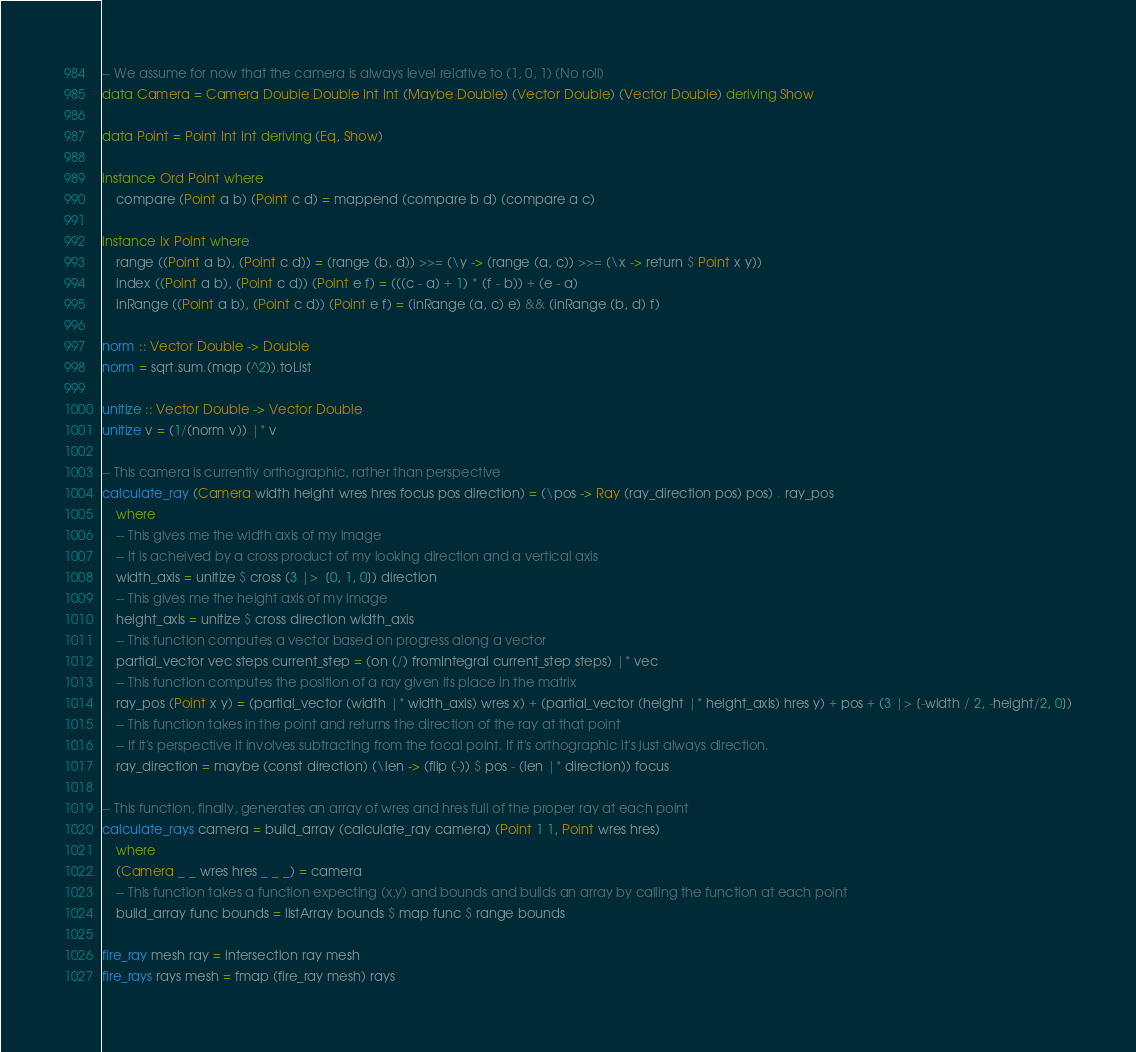<code> <loc_0><loc_0><loc_500><loc_500><_Haskell_>-- We assume for now that the camera is always level relative to (1, 0, 1) (No roll)
data Camera = Camera Double Double Int Int (Maybe Double) (Vector Double) (Vector Double) deriving Show

data Point = Point Int Int deriving (Eq, Show)

instance Ord Point where
	compare (Point a b) (Point c d) = mappend (compare b d) (compare a c)

instance Ix Point where
	range ((Point a b), (Point c d)) = (range (b, d)) >>= (\y -> (range (a, c)) >>= (\x -> return $ Point x y))
	index ((Point a b), (Point c d)) (Point e f) = (((c - a) + 1) * (f - b)) + (e - a)
	inRange ((Point a b), (Point c d)) (Point e f) = (inRange (a, c) e) && (inRange (b, d) f)

norm :: Vector Double -> Double
norm = sqrt.sum.(map (^2)).toList

unitize :: Vector Double -> Vector Double
unitize v = (1/(norm v)) |* v

-- This camera is currently orthographic, rather than perspective
calculate_ray (Camera width height wres hres focus pos direction) = (\pos -> Ray (ray_direction pos) pos) . ray_pos
	where
	-- This gives me the width axis of my image
	-- It is acheived by a cross product of my looking direction and a vertical axis
	width_axis = unitize $ cross (3 |>  [0, 1, 0]) direction
	-- This gives me the height axis of my image
	height_axis = unitize $ cross direction width_axis
	-- This function computes a vector based on progress along a vector
	partial_vector vec steps current_step = (on (/) fromIntegral current_step steps) |* vec
	-- This function computes the position of a ray given its place in the matrix
	ray_pos (Point x y) = (partial_vector (width |* width_axis) wres x) + (partial_vector (height |* height_axis) hres y) + pos + (3 |> [-width / 2, -height/2, 0])
	-- This function takes in the point and returns the direction of the ray at that point
	-- If it's perspective it involves subtracting from the focal point. If it's orthographic it's just always direction.
	ray_direction = maybe (const direction) (\len -> (flip (-)) $ pos - (len |* direction)) focus

-- This function, finally, generates an array of wres and hres full of the proper ray at each point
calculate_rays camera = build_array (calculate_ray camera) (Point 1 1, Point wres hres)
	where
	(Camera _ _ wres hres _ _ _) = camera
	-- This function takes a function expecting (x,y) and bounds and builds an array by calling the function at each point
	build_array func bounds = listArray bounds $ map func $ range bounds

fire_ray mesh ray = intersection ray mesh
fire_rays rays mesh = fmap (fire_ray mesh) rays
</code> 